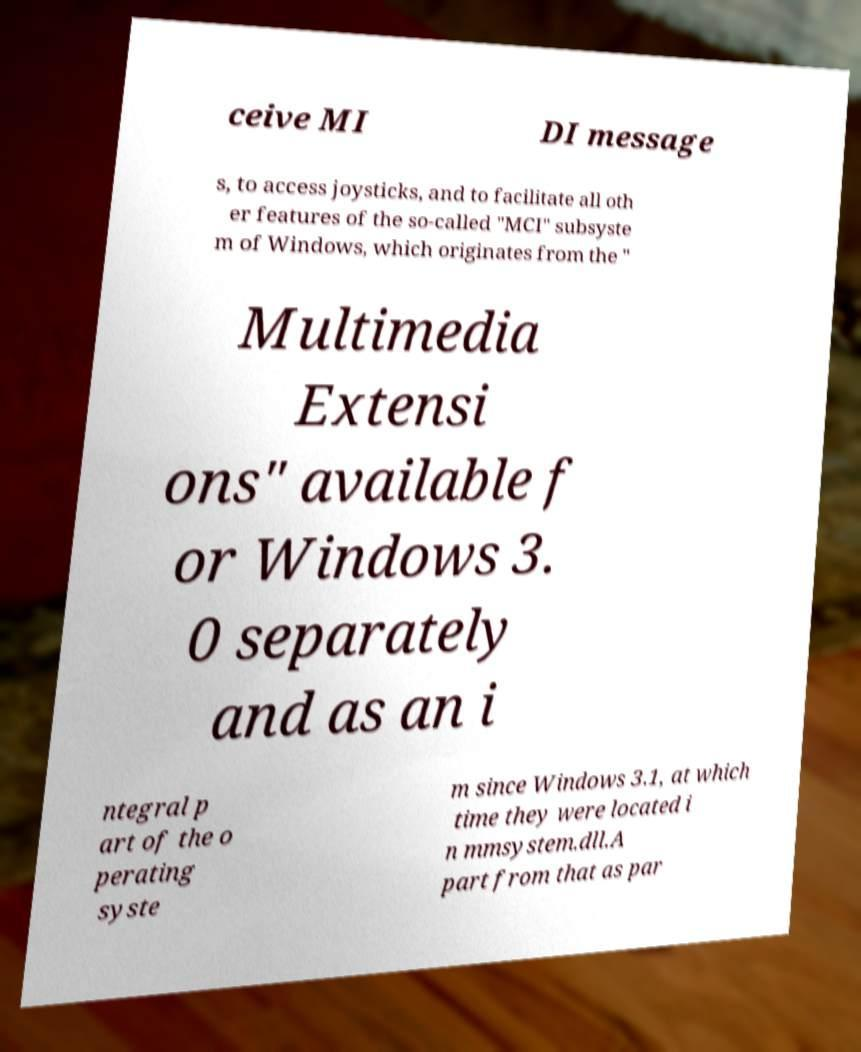Can you read and provide the text displayed in the image?This photo seems to have some interesting text. Can you extract and type it out for me? ceive MI DI message s, to access joysticks, and to facilitate all oth er features of the so-called "MCI" subsyste m of Windows, which originates from the " Multimedia Extensi ons" available f or Windows 3. 0 separately and as an i ntegral p art of the o perating syste m since Windows 3.1, at which time they were located i n mmsystem.dll.A part from that as par 